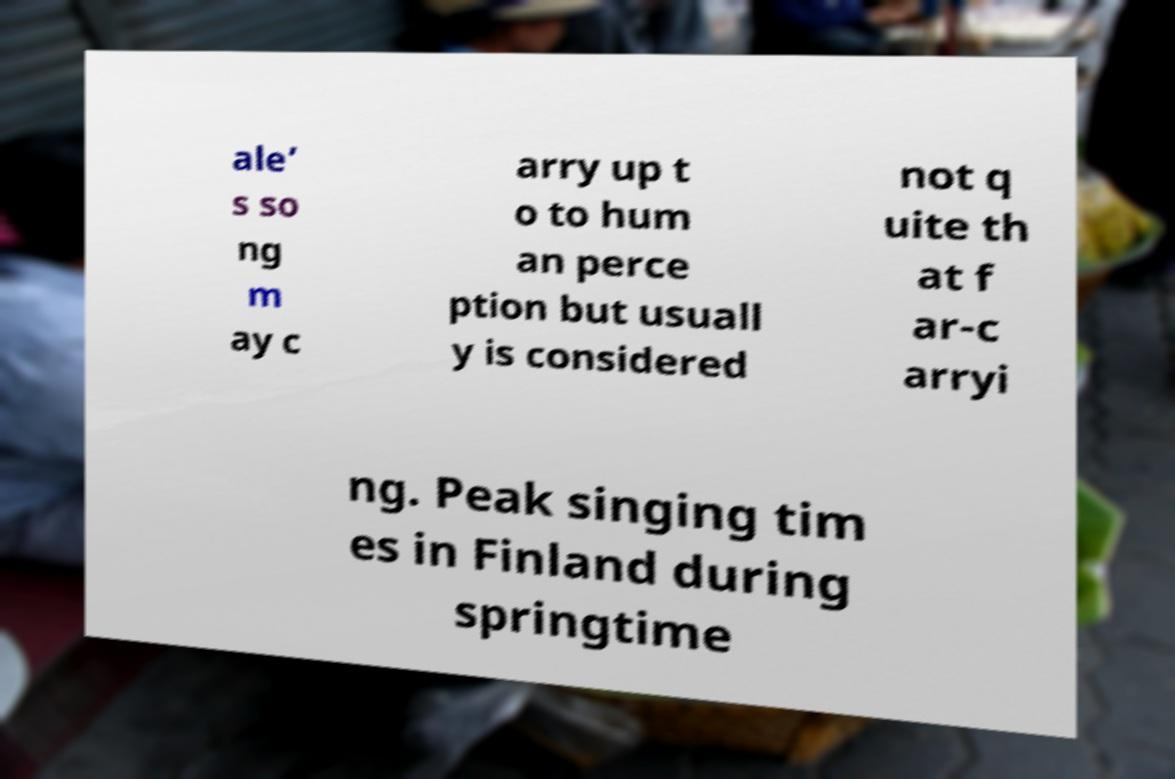For documentation purposes, I need the text within this image transcribed. Could you provide that? ale’ s so ng m ay c arry up t o to hum an perce ption but usuall y is considered not q uite th at f ar-c arryi ng. Peak singing tim es in Finland during springtime 